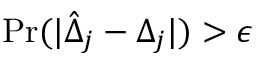<formula> <loc_0><loc_0><loc_500><loc_500>P r ( | \hat { \Delta } _ { j } - { \Delta } _ { j } | ) > \epsilon</formula> 